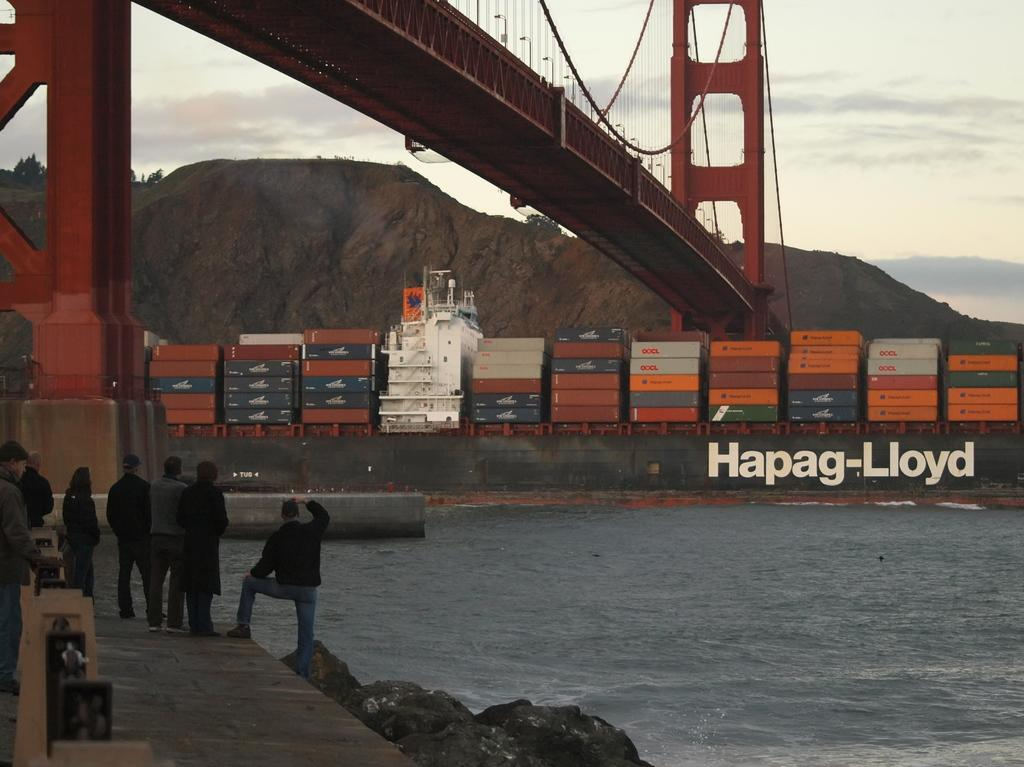How many people are in the group visible in the image? There is a group of people standing in the image, but the exact number cannot be determined from the provided facts. What type of natural feature can be seen in the image? There are rocks, water, and hills visible in the image. What man-made structure is visible in the image? The Golden Gate Bridge is visible in the image. What else can be seen in the image besides the people and the bridge? There are containers and the sky visible in the image. What type of tin is being used by the police in the image? There is no tin or police present in the image. What is the significance of the fifth element in the image? There are no elements numbered in the image, so it is not possible to determine the significance of a fifth element. 